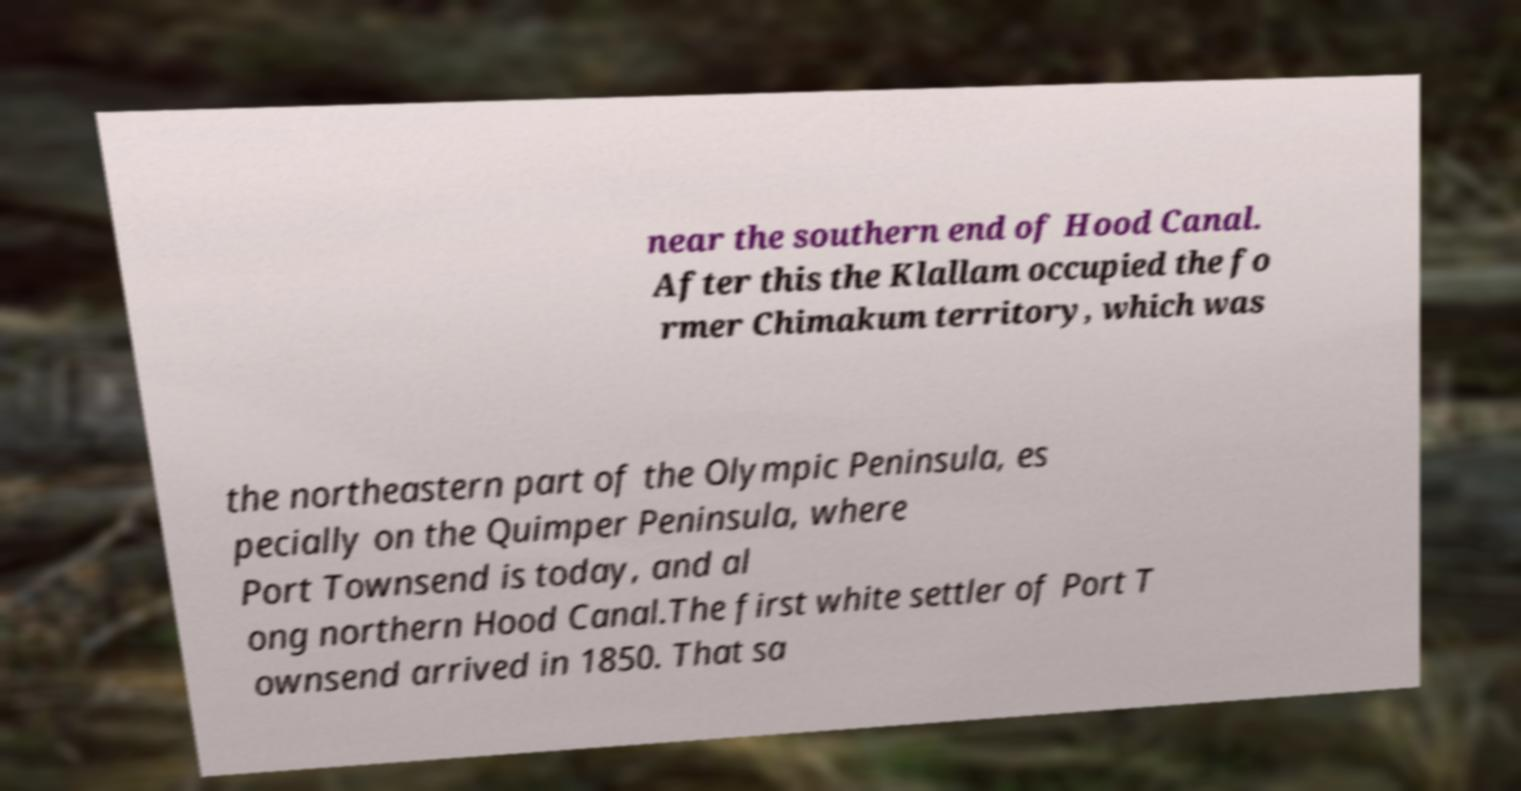Can you accurately transcribe the text from the provided image for me? near the southern end of Hood Canal. After this the Klallam occupied the fo rmer Chimakum territory, which was the northeastern part of the Olympic Peninsula, es pecially on the Quimper Peninsula, where Port Townsend is today, and al ong northern Hood Canal.The first white settler of Port T ownsend arrived in 1850. That sa 